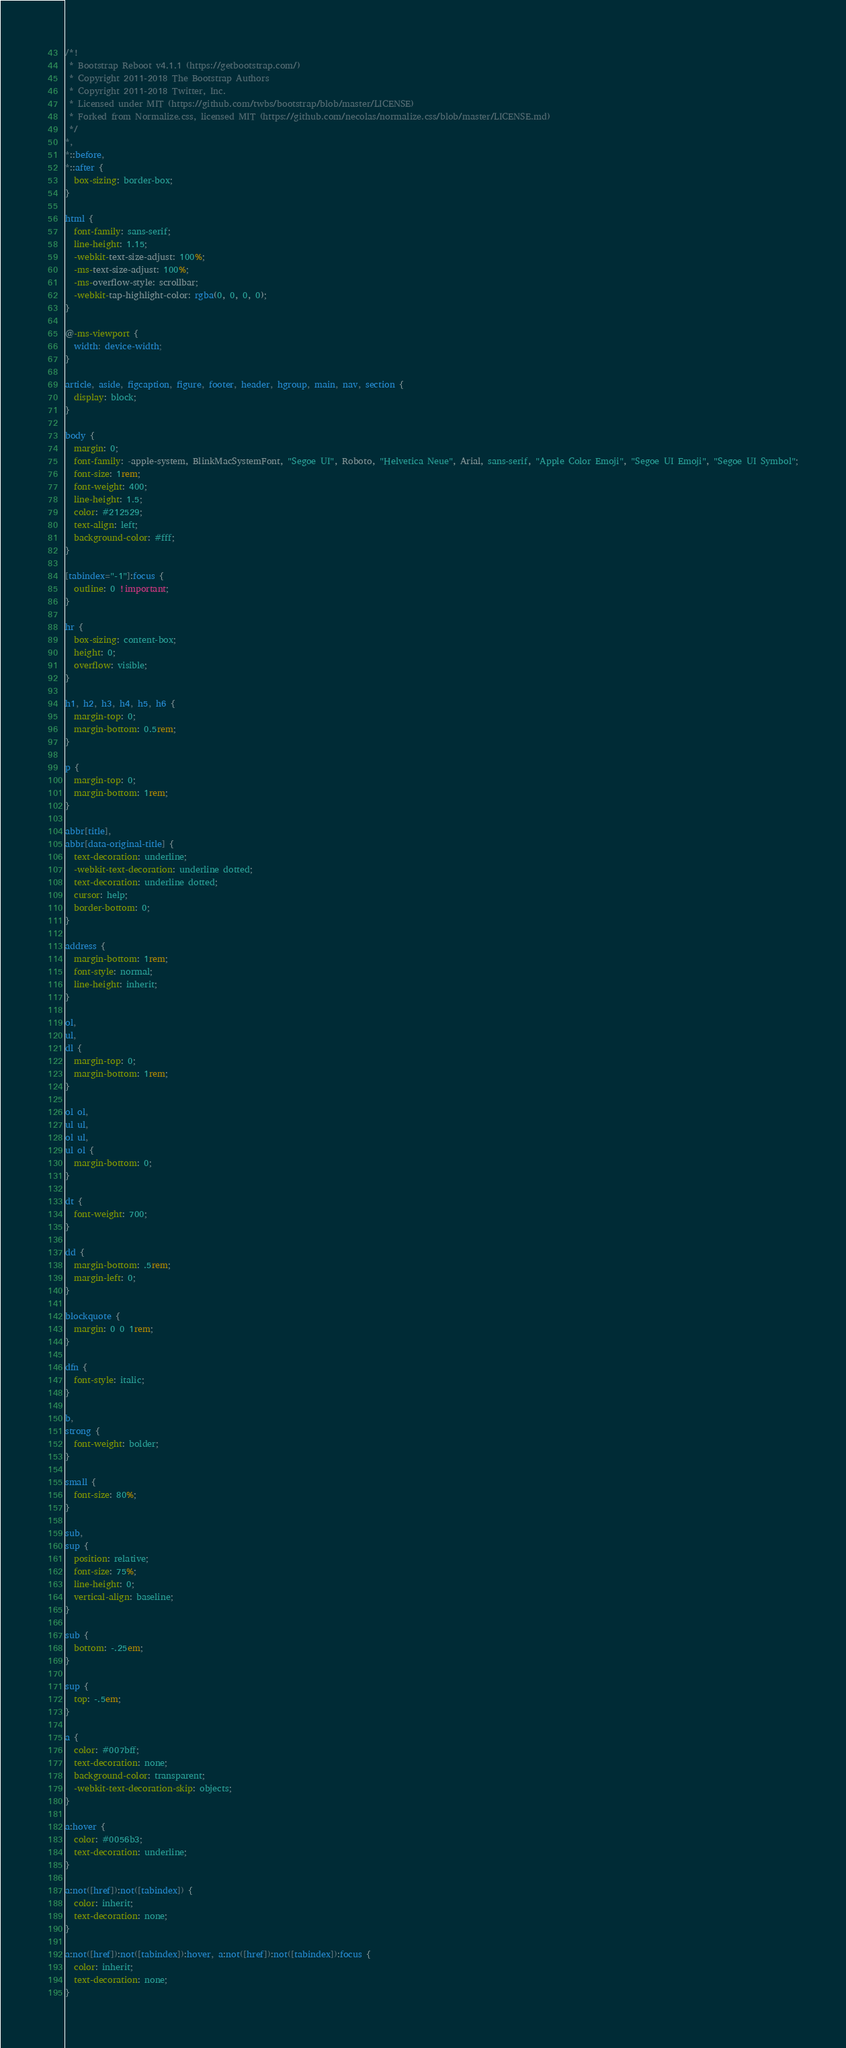<code> <loc_0><loc_0><loc_500><loc_500><_CSS_>/*!
 * Bootstrap Reboot v4.1.1 (https://getbootstrap.com/)
 * Copyright 2011-2018 The Bootstrap Authors
 * Copyright 2011-2018 Twitter, Inc.
 * Licensed under MIT (https://github.com/twbs/bootstrap/blob/master/LICENSE)
 * Forked from Normalize.css, licensed MIT (https://github.com/necolas/normalize.css/blob/master/LICENSE.md)
 */
*,
*::before,
*::after {
  box-sizing: border-box;
}

html {
  font-family: sans-serif;
  line-height: 1.15;
  -webkit-text-size-adjust: 100%;
  -ms-text-size-adjust: 100%;
  -ms-overflow-style: scrollbar;
  -webkit-tap-highlight-color: rgba(0, 0, 0, 0);
}

@-ms-viewport {
  width: device-width;
}

article, aside, figcaption, figure, footer, header, hgroup, main, nav, section {
  display: block;
}

body {
  margin: 0;
  font-family: -apple-system, BlinkMacSystemFont, "Segoe UI", Roboto, "Helvetica Neue", Arial, sans-serif, "Apple Color Emoji", "Segoe UI Emoji", "Segoe UI Symbol";
  font-size: 1rem;
  font-weight: 400;
  line-height: 1.5;
  color: #212529;
  text-align: left;
  background-color: #fff;
}

[tabindex="-1"]:focus {
  outline: 0 !important;
}

hr {
  box-sizing: content-box;
  height: 0;
  overflow: visible;
}

h1, h2, h3, h4, h5, h6 {
  margin-top: 0;
  margin-bottom: 0.5rem;
}

p {
  margin-top: 0;
  margin-bottom: 1rem;
}

abbr[title],
abbr[data-original-title] {
  text-decoration: underline;
  -webkit-text-decoration: underline dotted;
  text-decoration: underline dotted;
  cursor: help;
  border-bottom: 0;
}

address {
  margin-bottom: 1rem;
  font-style: normal;
  line-height: inherit;
}

ol,
ul,
dl {
  margin-top: 0;
  margin-bottom: 1rem;
}

ol ol,
ul ul,
ol ul,
ul ol {
  margin-bottom: 0;
}

dt {
  font-weight: 700;
}

dd {
  margin-bottom: .5rem;
  margin-left: 0;
}

blockquote {
  margin: 0 0 1rem;
}

dfn {
  font-style: italic;
}

b,
strong {
  font-weight: bolder;
}

small {
  font-size: 80%;
}

sub,
sup {
  position: relative;
  font-size: 75%;
  line-height: 0;
  vertical-align: baseline;
}

sub {
  bottom: -.25em;
}

sup {
  top: -.5em;
}

a {
  color: #007bff;
  text-decoration: none;
  background-color: transparent;
  -webkit-text-decoration-skip: objects;
}

a:hover {
  color: #0056b3;
  text-decoration: underline;
}

a:not([href]):not([tabindex]) {
  color: inherit;
  text-decoration: none;
}

a:not([href]):not([tabindex]):hover, a:not([href]):not([tabindex]):focus {
  color: inherit;
  text-decoration: none;
}
</code> 